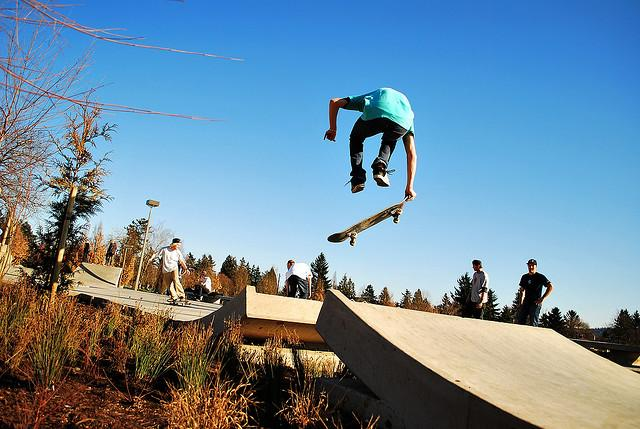Why is he grabbing the board? doing trick 